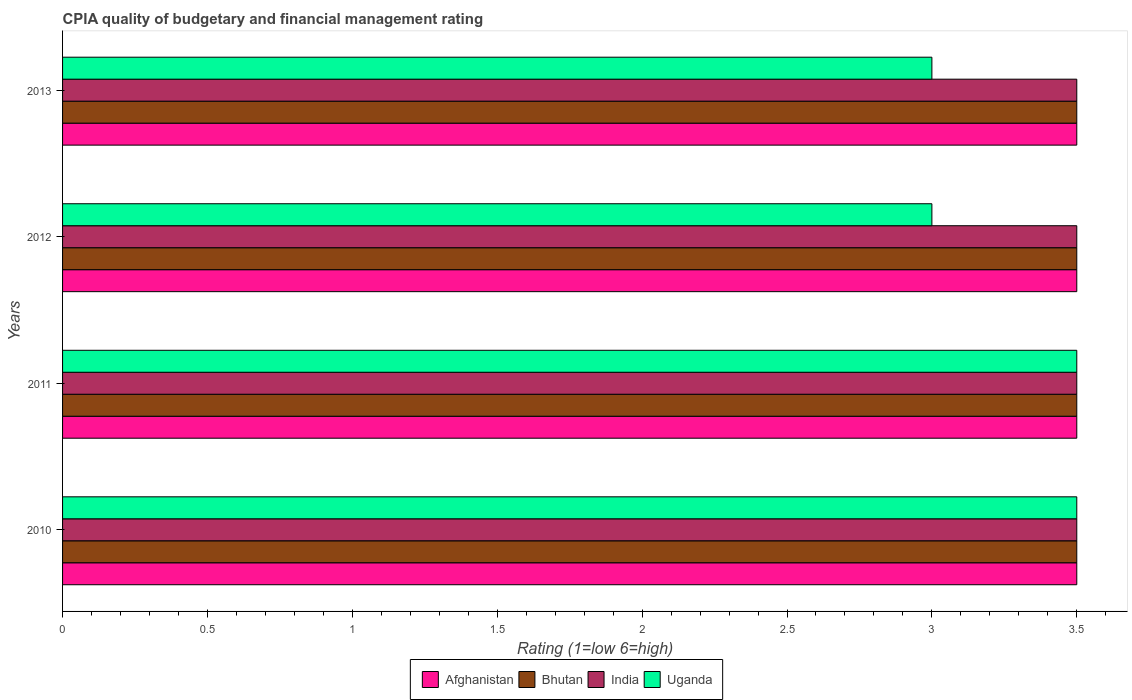How many different coloured bars are there?
Make the answer very short. 4. How many groups of bars are there?
Offer a terse response. 4. Are the number of bars on each tick of the Y-axis equal?
Offer a terse response. Yes. How many bars are there on the 2nd tick from the top?
Your answer should be compact. 4. How many bars are there on the 2nd tick from the bottom?
Offer a terse response. 4. What is the label of the 1st group of bars from the top?
Provide a succinct answer. 2013. In how many cases, is the number of bars for a given year not equal to the number of legend labels?
Ensure brevity in your answer.  0. What is the CPIA rating in Afghanistan in 2012?
Ensure brevity in your answer.  3.5. Across all years, what is the minimum CPIA rating in Uganda?
Provide a succinct answer. 3. What is the difference between the highest and the second highest CPIA rating in Uganda?
Offer a very short reply. 0. Is the sum of the CPIA rating in Afghanistan in 2010 and 2013 greater than the maximum CPIA rating in Uganda across all years?
Offer a very short reply. Yes. Is it the case that in every year, the sum of the CPIA rating in India and CPIA rating in Bhutan is greater than the sum of CPIA rating in Afghanistan and CPIA rating in Uganda?
Ensure brevity in your answer.  No. What does the 1st bar from the top in 2010 represents?
Provide a succinct answer. Uganda. What does the 1st bar from the bottom in 2010 represents?
Offer a terse response. Afghanistan. Is it the case that in every year, the sum of the CPIA rating in India and CPIA rating in Bhutan is greater than the CPIA rating in Afghanistan?
Your answer should be compact. Yes. Are all the bars in the graph horizontal?
Keep it short and to the point. Yes. How many years are there in the graph?
Offer a terse response. 4. What is the difference between two consecutive major ticks on the X-axis?
Give a very brief answer. 0.5. Are the values on the major ticks of X-axis written in scientific E-notation?
Provide a succinct answer. No. Where does the legend appear in the graph?
Offer a very short reply. Bottom center. What is the title of the graph?
Your answer should be very brief. CPIA quality of budgetary and financial management rating. Does "Benin" appear as one of the legend labels in the graph?
Provide a short and direct response. No. What is the label or title of the X-axis?
Offer a very short reply. Rating (1=low 6=high). What is the Rating (1=low 6=high) in Bhutan in 2010?
Provide a short and direct response. 3.5. What is the Rating (1=low 6=high) in India in 2010?
Offer a terse response. 3.5. What is the Rating (1=low 6=high) of Bhutan in 2011?
Make the answer very short. 3.5. What is the Rating (1=low 6=high) of Uganda in 2012?
Keep it short and to the point. 3. What is the Rating (1=low 6=high) of Bhutan in 2013?
Your answer should be very brief. 3.5. What is the Rating (1=low 6=high) in India in 2013?
Make the answer very short. 3.5. What is the Rating (1=low 6=high) of Uganda in 2013?
Make the answer very short. 3. Across all years, what is the maximum Rating (1=low 6=high) in Afghanistan?
Offer a very short reply. 3.5. Across all years, what is the maximum Rating (1=low 6=high) of Bhutan?
Provide a succinct answer. 3.5. Across all years, what is the maximum Rating (1=low 6=high) in India?
Provide a succinct answer. 3.5. Across all years, what is the minimum Rating (1=low 6=high) of Bhutan?
Keep it short and to the point. 3.5. Across all years, what is the minimum Rating (1=low 6=high) in India?
Ensure brevity in your answer.  3.5. Across all years, what is the minimum Rating (1=low 6=high) in Uganda?
Provide a short and direct response. 3. What is the total Rating (1=low 6=high) in Afghanistan in the graph?
Your response must be concise. 14. What is the difference between the Rating (1=low 6=high) of Afghanistan in 2010 and that in 2011?
Make the answer very short. 0. What is the difference between the Rating (1=low 6=high) in Bhutan in 2010 and that in 2011?
Make the answer very short. 0. What is the difference between the Rating (1=low 6=high) of Bhutan in 2010 and that in 2012?
Provide a short and direct response. 0. What is the difference between the Rating (1=low 6=high) in India in 2010 and that in 2012?
Keep it short and to the point. 0. What is the difference between the Rating (1=low 6=high) in Afghanistan in 2010 and that in 2013?
Provide a short and direct response. 0. What is the difference between the Rating (1=low 6=high) in Uganda in 2010 and that in 2013?
Offer a terse response. 0.5. What is the difference between the Rating (1=low 6=high) of Bhutan in 2011 and that in 2012?
Offer a very short reply. 0. What is the difference between the Rating (1=low 6=high) in Uganda in 2011 and that in 2012?
Your answer should be compact. 0.5. What is the difference between the Rating (1=low 6=high) in Afghanistan in 2011 and that in 2013?
Your answer should be compact. 0. What is the difference between the Rating (1=low 6=high) of India in 2011 and that in 2013?
Make the answer very short. 0. What is the difference between the Rating (1=low 6=high) in Afghanistan in 2012 and that in 2013?
Your answer should be very brief. 0. What is the difference between the Rating (1=low 6=high) in Bhutan in 2012 and that in 2013?
Ensure brevity in your answer.  0. What is the difference between the Rating (1=low 6=high) of Uganda in 2012 and that in 2013?
Keep it short and to the point. 0. What is the difference between the Rating (1=low 6=high) in Afghanistan in 2010 and the Rating (1=low 6=high) in Bhutan in 2011?
Offer a terse response. 0. What is the difference between the Rating (1=low 6=high) in Afghanistan in 2010 and the Rating (1=low 6=high) in India in 2011?
Your response must be concise. 0. What is the difference between the Rating (1=low 6=high) in Bhutan in 2010 and the Rating (1=low 6=high) in India in 2011?
Provide a short and direct response. 0. What is the difference between the Rating (1=low 6=high) of Afghanistan in 2010 and the Rating (1=low 6=high) of India in 2012?
Your answer should be compact. 0. What is the difference between the Rating (1=low 6=high) of Bhutan in 2010 and the Rating (1=low 6=high) of India in 2012?
Make the answer very short. 0. What is the difference between the Rating (1=low 6=high) in Bhutan in 2010 and the Rating (1=low 6=high) in Uganda in 2012?
Your answer should be compact. 0.5. What is the difference between the Rating (1=low 6=high) of Afghanistan in 2010 and the Rating (1=low 6=high) of Bhutan in 2013?
Make the answer very short. 0. What is the difference between the Rating (1=low 6=high) in Afghanistan in 2010 and the Rating (1=low 6=high) in India in 2013?
Keep it short and to the point. 0. What is the difference between the Rating (1=low 6=high) of Bhutan in 2010 and the Rating (1=low 6=high) of India in 2013?
Your response must be concise. 0. What is the difference between the Rating (1=low 6=high) of Bhutan in 2011 and the Rating (1=low 6=high) of India in 2012?
Ensure brevity in your answer.  0. What is the difference between the Rating (1=low 6=high) of Bhutan in 2011 and the Rating (1=low 6=high) of Uganda in 2012?
Offer a terse response. 0.5. What is the difference between the Rating (1=low 6=high) of India in 2011 and the Rating (1=low 6=high) of Uganda in 2012?
Give a very brief answer. 0.5. What is the difference between the Rating (1=low 6=high) in Afghanistan in 2011 and the Rating (1=low 6=high) in Bhutan in 2013?
Keep it short and to the point. 0. What is the difference between the Rating (1=low 6=high) in India in 2011 and the Rating (1=low 6=high) in Uganda in 2013?
Ensure brevity in your answer.  0.5. What is the difference between the Rating (1=low 6=high) in Afghanistan in 2012 and the Rating (1=low 6=high) in Bhutan in 2013?
Your answer should be compact. 0. What is the difference between the Rating (1=low 6=high) of Afghanistan in 2012 and the Rating (1=low 6=high) of Uganda in 2013?
Offer a very short reply. 0.5. What is the difference between the Rating (1=low 6=high) of Bhutan in 2012 and the Rating (1=low 6=high) of India in 2013?
Ensure brevity in your answer.  0. What is the average Rating (1=low 6=high) in Afghanistan per year?
Your answer should be very brief. 3.5. What is the average Rating (1=low 6=high) in India per year?
Keep it short and to the point. 3.5. What is the average Rating (1=low 6=high) in Uganda per year?
Offer a terse response. 3.25. In the year 2010, what is the difference between the Rating (1=low 6=high) in Afghanistan and Rating (1=low 6=high) in Bhutan?
Provide a succinct answer. 0. In the year 2010, what is the difference between the Rating (1=low 6=high) in Afghanistan and Rating (1=low 6=high) in Uganda?
Make the answer very short. 0. In the year 2010, what is the difference between the Rating (1=low 6=high) of Bhutan and Rating (1=low 6=high) of Uganda?
Offer a terse response. 0. In the year 2010, what is the difference between the Rating (1=low 6=high) of India and Rating (1=low 6=high) of Uganda?
Provide a short and direct response. 0. In the year 2011, what is the difference between the Rating (1=low 6=high) in Bhutan and Rating (1=low 6=high) in India?
Make the answer very short. 0. In the year 2012, what is the difference between the Rating (1=low 6=high) in Afghanistan and Rating (1=low 6=high) in Bhutan?
Offer a terse response. 0. In the year 2012, what is the difference between the Rating (1=low 6=high) in Bhutan and Rating (1=low 6=high) in India?
Give a very brief answer. 0. In the year 2013, what is the difference between the Rating (1=low 6=high) in Afghanistan and Rating (1=low 6=high) in Uganda?
Your response must be concise. 0.5. In the year 2013, what is the difference between the Rating (1=low 6=high) in Bhutan and Rating (1=low 6=high) in India?
Your answer should be compact. 0. In the year 2013, what is the difference between the Rating (1=low 6=high) in Bhutan and Rating (1=low 6=high) in Uganda?
Provide a succinct answer. 0.5. In the year 2013, what is the difference between the Rating (1=low 6=high) in India and Rating (1=low 6=high) in Uganda?
Provide a short and direct response. 0.5. What is the ratio of the Rating (1=low 6=high) of Afghanistan in 2010 to that in 2011?
Provide a succinct answer. 1. What is the ratio of the Rating (1=low 6=high) in Uganda in 2010 to that in 2011?
Offer a very short reply. 1. What is the ratio of the Rating (1=low 6=high) of Afghanistan in 2010 to that in 2012?
Provide a succinct answer. 1. What is the ratio of the Rating (1=low 6=high) of Bhutan in 2010 to that in 2012?
Offer a terse response. 1. What is the ratio of the Rating (1=low 6=high) of India in 2010 to that in 2012?
Make the answer very short. 1. What is the ratio of the Rating (1=low 6=high) of Afghanistan in 2010 to that in 2013?
Offer a terse response. 1. What is the ratio of the Rating (1=low 6=high) of India in 2011 to that in 2012?
Keep it short and to the point. 1. What is the ratio of the Rating (1=low 6=high) of Uganda in 2011 to that in 2012?
Your answer should be very brief. 1.17. What is the ratio of the Rating (1=low 6=high) in Afghanistan in 2011 to that in 2013?
Make the answer very short. 1. What is the ratio of the Rating (1=low 6=high) in Bhutan in 2011 to that in 2013?
Offer a terse response. 1. What is the ratio of the Rating (1=low 6=high) of Uganda in 2011 to that in 2013?
Offer a terse response. 1.17. What is the ratio of the Rating (1=low 6=high) in Afghanistan in 2012 to that in 2013?
Ensure brevity in your answer.  1. What is the ratio of the Rating (1=low 6=high) of Uganda in 2012 to that in 2013?
Keep it short and to the point. 1. What is the difference between the highest and the second highest Rating (1=low 6=high) in Afghanistan?
Offer a very short reply. 0. What is the difference between the highest and the second highest Rating (1=low 6=high) in Bhutan?
Provide a short and direct response. 0. What is the difference between the highest and the second highest Rating (1=low 6=high) in India?
Ensure brevity in your answer.  0. What is the difference between the highest and the second highest Rating (1=low 6=high) in Uganda?
Your response must be concise. 0. What is the difference between the highest and the lowest Rating (1=low 6=high) of Bhutan?
Your answer should be very brief. 0. 